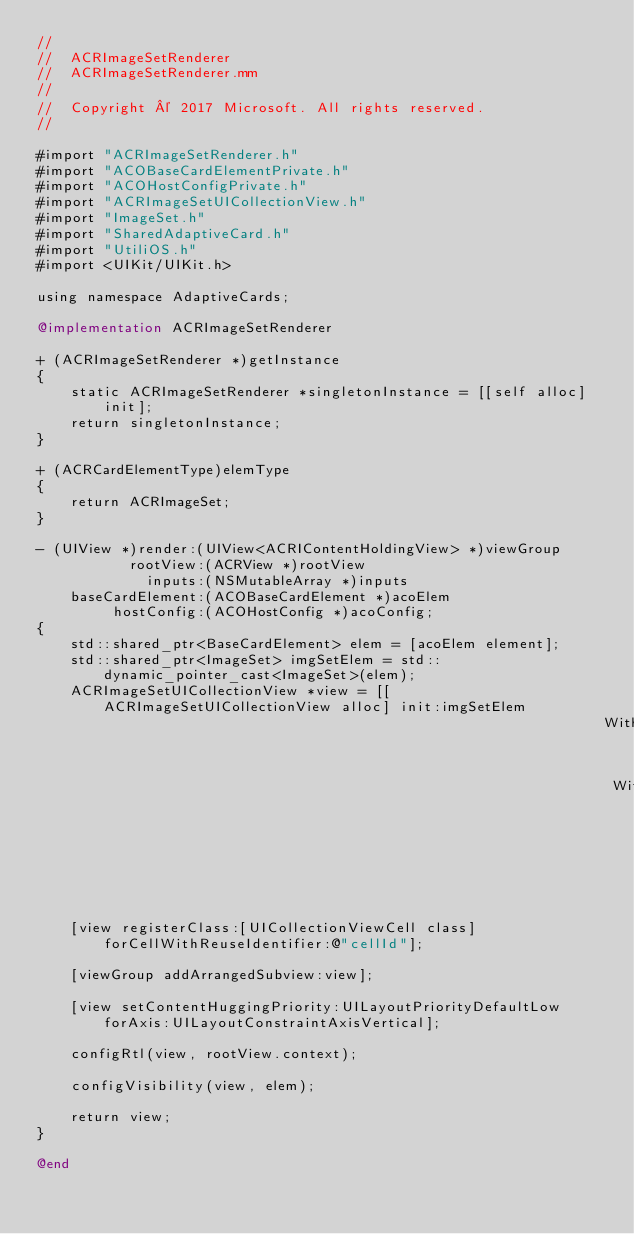Convert code to text. <code><loc_0><loc_0><loc_500><loc_500><_ObjectiveC_>//
//  ACRImageSetRenderer
//  ACRImageSetRenderer.mm
//
//  Copyright © 2017 Microsoft. All rights reserved.
//

#import "ACRImageSetRenderer.h"
#import "ACOBaseCardElementPrivate.h"
#import "ACOHostConfigPrivate.h"
#import "ACRImageSetUICollectionView.h"
#import "ImageSet.h"
#import "SharedAdaptiveCard.h"
#import "UtiliOS.h"
#import <UIKit/UIKit.h>

using namespace AdaptiveCards;

@implementation ACRImageSetRenderer

+ (ACRImageSetRenderer *)getInstance
{
    static ACRImageSetRenderer *singletonInstance = [[self alloc] init];
    return singletonInstance;
}

+ (ACRCardElementType)elemType
{
    return ACRImageSet;
}

- (UIView *)render:(UIView<ACRIContentHoldingView> *)viewGroup
           rootView:(ACRView *)rootView
             inputs:(NSMutableArray *)inputs
    baseCardElement:(ACOBaseCardElement *)acoElem
         hostConfig:(ACOHostConfig *)acoConfig;
{
    std::shared_ptr<BaseCardElement> elem = [acoElem element];
    std::shared_ptr<ImageSet> imgSetElem = std::dynamic_pointer_cast<ImageSet>(elem);
    ACRImageSetUICollectionView *view = [[ACRImageSetUICollectionView alloc] init:imgSetElem
                                                                   WithHostConfig:acoConfig
                                                                    WithSuperview:viewGroup
                                                                         rootView:rootView];
    [view registerClass:[UICollectionViewCell class] forCellWithReuseIdentifier:@"cellId"];

    [viewGroup addArrangedSubview:view];

    [view setContentHuggingPriority:UILayoutPriorityDefaultLow forAxis:UILayoutConstraintAxisVertical];

    configRtl(view, rootView.context);

    configVisibility(view, elem);

    return view;
}

@end
</code> 